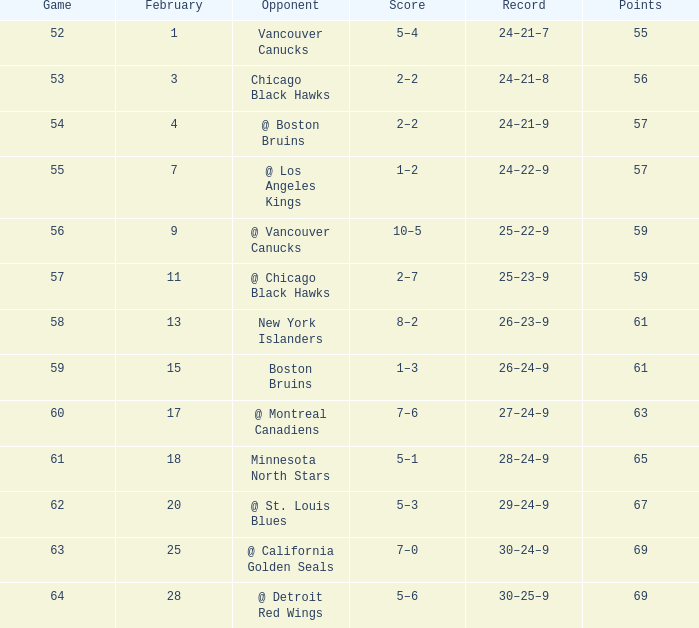Which adversary has a match greater than 61, february less than 28, and lesser points than 69? @ St. Louis Blues. 